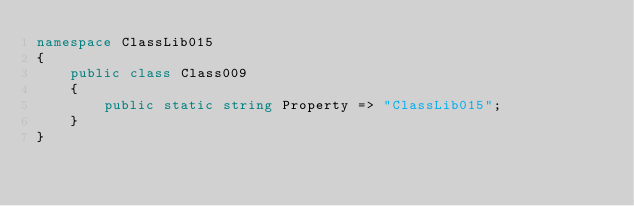<code> <loc_0><loc_0><loc_500><loc_500><_C#_>namespace ClassLib015
{
    public class Class009
    {
        public static string Property => "ClassLib015";
    }
}
</code> 